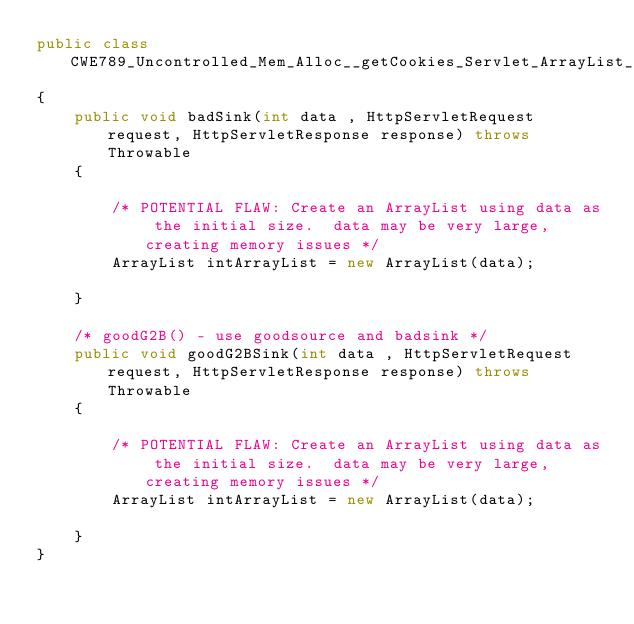<code> <loc_0><loc_0><loc_500><loc_500><_Java_>public class CWE789_Uncontrolled_Mem_Alloc__getCookies_Servlet_ArrayList_54e
{
    public void badSink(int data , HttpServletRequest request, HttpServletResponse response) throws Throwable
    {

        /* POTENTIAL FLAW: Create an ArrayList using data as the initial size.  data may be very large, creating memory issues */
        ArrayList intArrayList = new ArrayList(data);

    }

    /* goodG2B() - use goodsource and badsink */
    public void goodG2BSink(int data , HttpServletRequest request, HttpServletResponse response) throws Throwable
    {

        /* POTENTIAL FLAW: Create an ArrayList using data as the initial size.  data may be very large, creating memory issues */
        ArrayList intArrayList = new ArrayList(data);

    }
}
</code> 